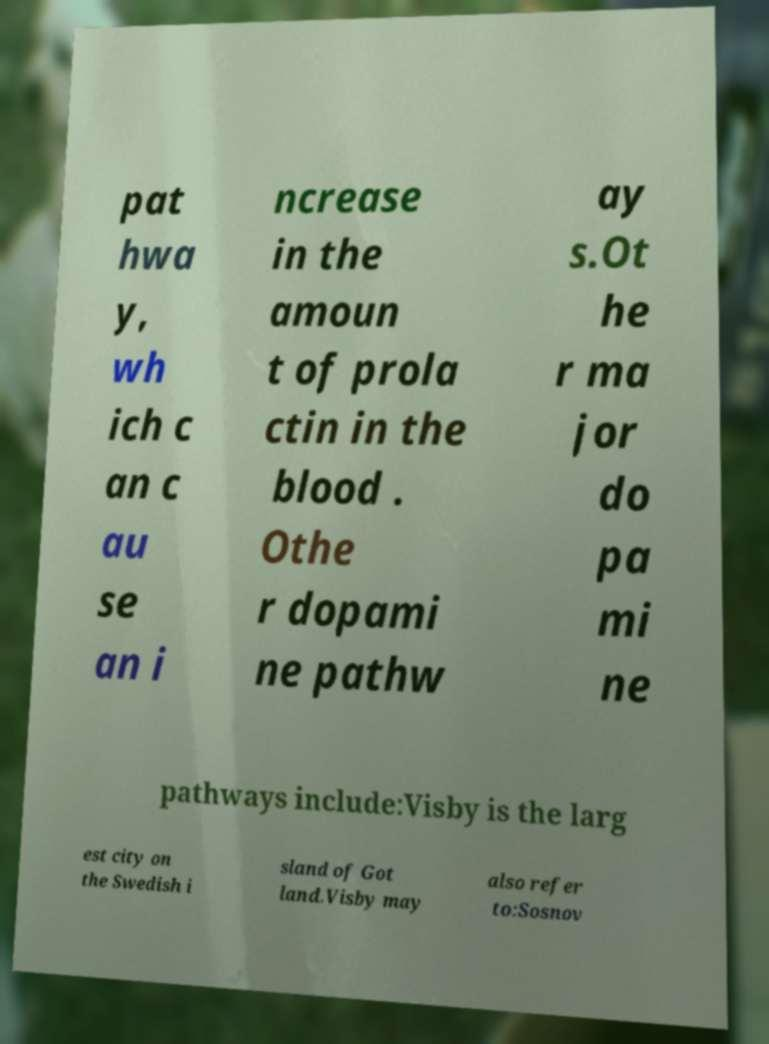Can you read and provide the text displayed in the image?This photo seems to have some interesting text. Can you extract and type it out for me? pat hwa y, wh ich c an c au se an i ncrease in the amoun t of prola ctin in the blood . Othe r dopami ne pathw ay s.Ot he r ma jor do pa mi ne pathways include:Visby is the larg est city on the Swedish i sland of Got land.Visby may also refer to:Sosnov 